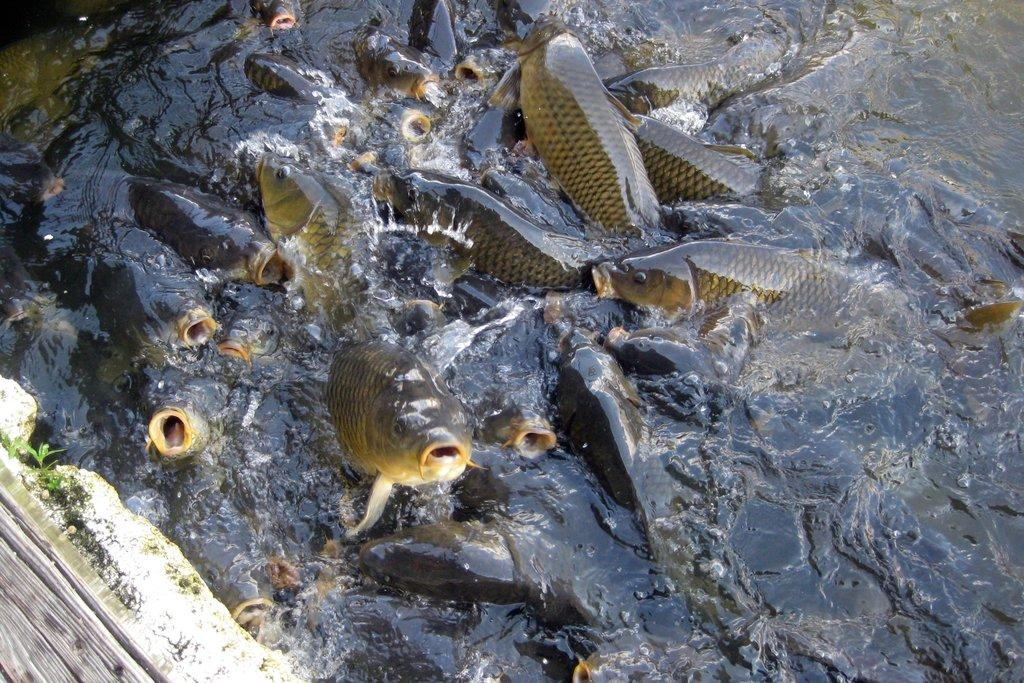What type of animals can be seen in the water in the image? There are huge fish in the water in the image. What is located in the bottom left corner of the image? There is a wall, plants, and a log in the bottom left corner of the image. What type of scarecrow can be seen in the image? There is no scarecrow present in the image. What is the mind of the fish in the image thinking? It is impossible to determine the thoughts or mental state of the fish in the image, as they are not human and do not have minds in the same way that humans do. 